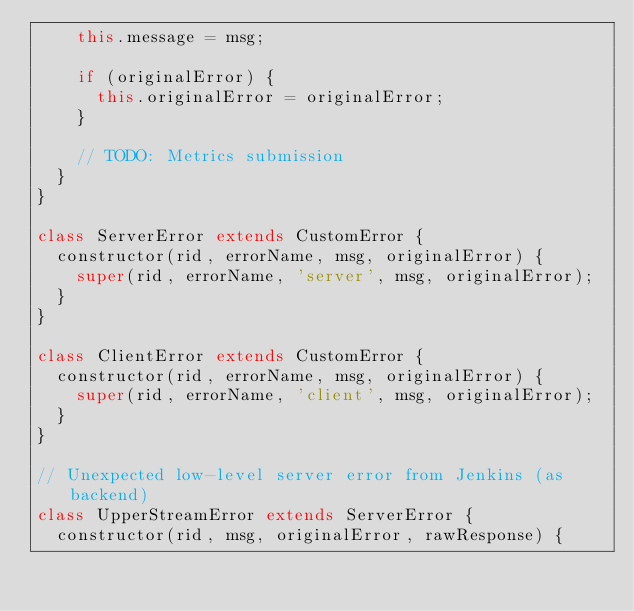Convert code to text. <code><loc_0><loc_0><loc_500><loc_500><_JavaScript_>    this.message = msg;

    if (originalError) {
      this.originalError = originalError;
    }

    // TODO: Metrics submission
  }
}

class ServerError extends CustomError {
  constructor(rid, errorName, msg, originalError) {
    super(rid, errorName, 'server', msg, originalError);
  }
}

class ClientError extends CustomError {
  constructor(rid, errorName, msg, originalError) {
    super(rid, errorName, 'client', msg, originalError);
  }
}

// Unexpected low-level server error from Jenkins (as backend)
class UpperStreamError extends ServerError {
  constructor(rid, msg, originalError, rawResponse) {</code> 